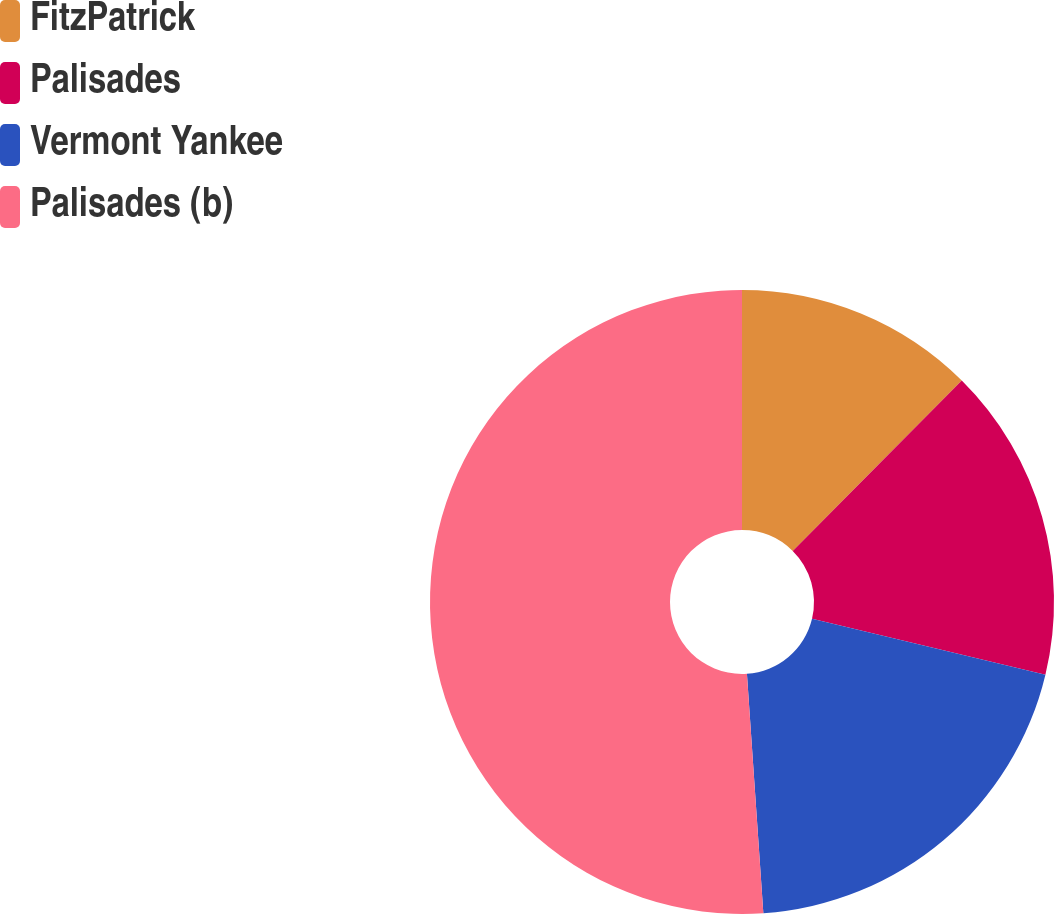Convert chart to OTSL. <chart><loc_0><loc_0><loc_500><loc_500><pie_chart><fcel>FitzPatrick<fcel>Palisades<fcel>Vermont Yankee<fcel>Palisades (b)<nl><fcel>12.44%<fcel>16.3%<fcel>20.17%<fcel>51.09%<nl></chart> 